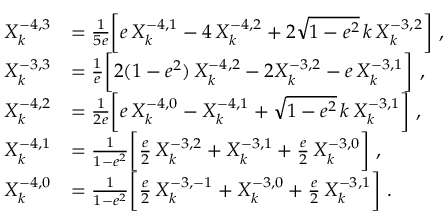<formula> <loc_0><loc_0><loc_500><loc_500>\begin{array} { r l } { X _ { k } ^ { - 4 , 3 } } & { = \frac { 1 } { 5 e } \left [ e \, X _ { k } ^ { - 4 , 1 } - 4 \, X _ { k } ^ { - 4 , 2 } + 2 \sqrt { 1 - e ^ { 2 } } \, k \, X _ { k } ^ { - 3 , 2 } \right ] \ , } \\ { X _ { k } ^ { - 3 , 3 } } & { = \frac { 1 } { e } \left [ 2 ( 1 - e ^ { 2 } ) \, X _ { k } ^ { - 4 , 2 } - 2 X _ { k } ^ { - 3 , 2 } - e \, X _ { k } ^ { - 3 , 1 } \right ] \ , } \\ { X _ { k } ^ { - 4 , 2 } } & { = \frac { 1 } { 2 e } \left [ e \, X _ { k } ^ { - 4 , 0 } - X _ { k } ^ { - 4 , 1 } + \sqrt { 1 - e ^ { 2 } } \, k \, X _ { k } ^ { - 3 , 1 } \right ] \ , } \\ { X _ { k } ^ { - 4 , 1 } } & { = \frac { 1 } { 1 - e ^ { 2 } } \left [ \frac { e } { 2 } \, X _ { k } ^ { - 3 , 2 } + X _ { k } ^ { - 3 , 1 } + \frac { e } { 2 } \, X _ { k } ^ { - 3 , 0 } \right ] \ , } \\ { X _ { k } ^ { - 4 , 0 } } & { = \frac { 1 } { 1 - e ^ { 2 } } \left [ \frac { e } { 2 } \, X _ { k } ^ { - 3 , - 1 } + X _ { k } ^ { - 3 , 0 } + \frac { e } { 2 } \, X _ { k } ^ { - 3 , 1 } \right ] \ . } \end{array}</formula> 